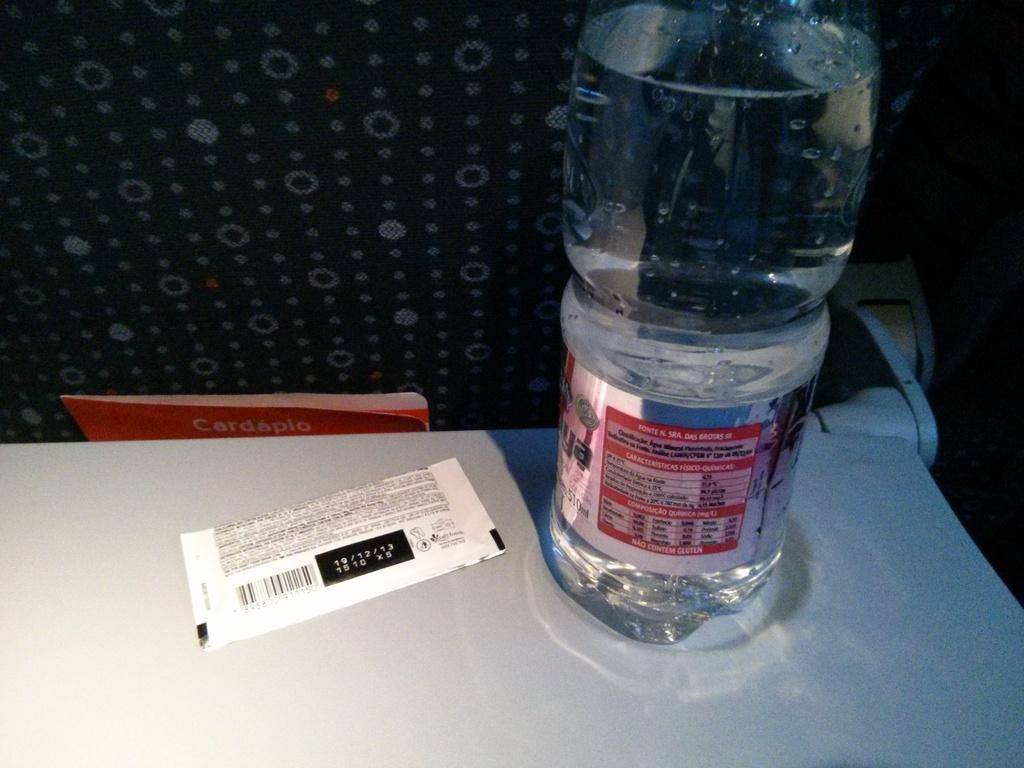<image>
Write a terse but informative summary of the picture. a large bottle of clear liquid next to a card with numbers 19/12/13 